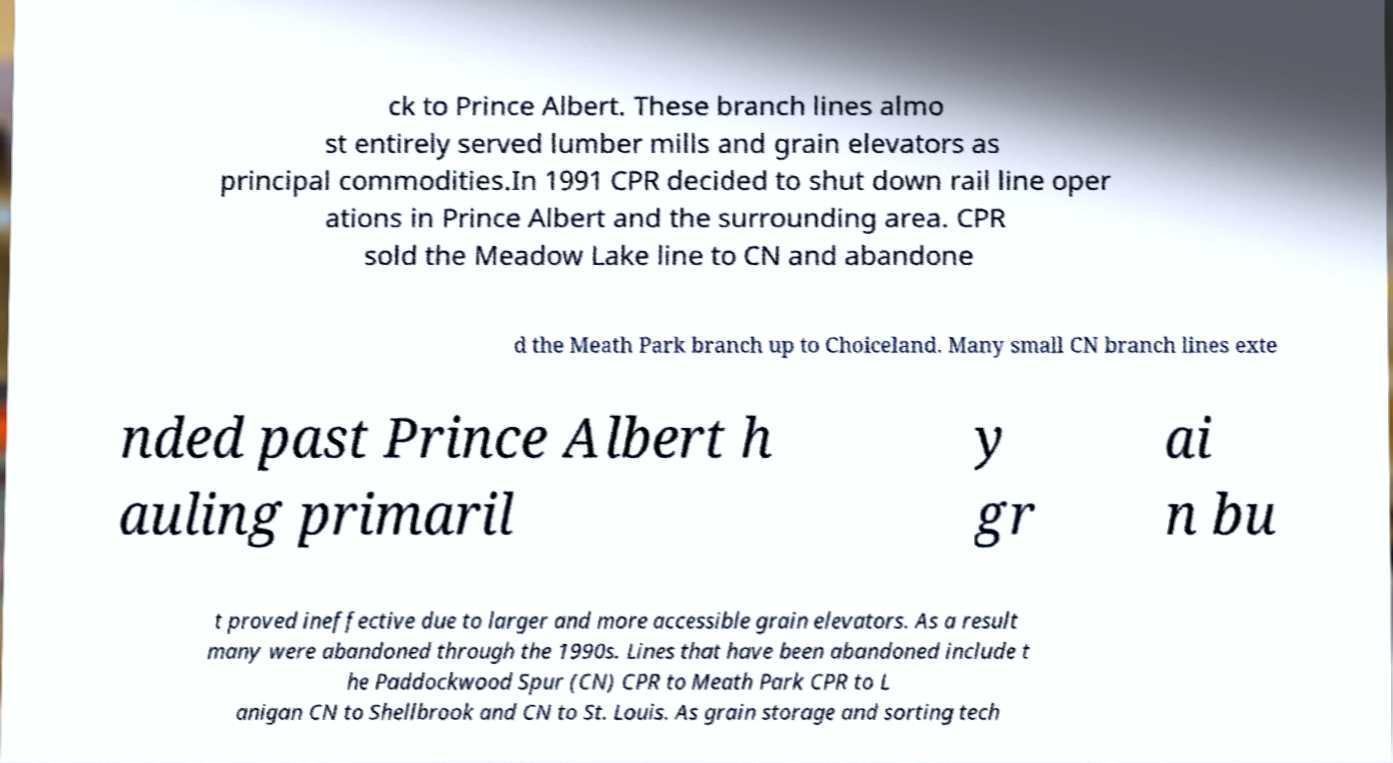Can you read and provide the text displayed in the image?This photo seems to have some interesting text. Can you extract and type it out for me? ck to Prince Albert. These branch lines almo st entirely served lumber mills and grain elevators as principal commodities.In 1991 CPR decided to shut down rail line oper ations in Prince Albert and the surrounding area. CPR sold the Meadow Lake line to CN and abandone d the Meath Park branch up to Choiceland. Many small CN branch lines exte nded past Prince Albert h auling primaril y gr ai n bu t proved ineffective due to larger and more accessible grain elevators. As a result many were abandoned through the 1990s. Lines that have been abandoned include t he Paddockwood Spur (CN) CPR to Meath Park CPR to L anigan CN to Shellbrook and CN to St. Louis. As grain storage and sorting tech 